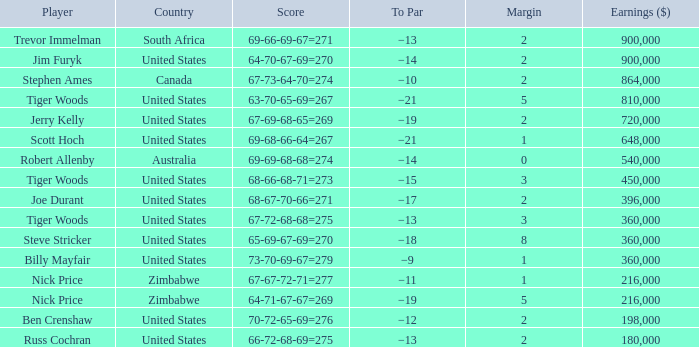For how many years has a player of joe durant accumulated over $396,000 in earnings? 0.0. 